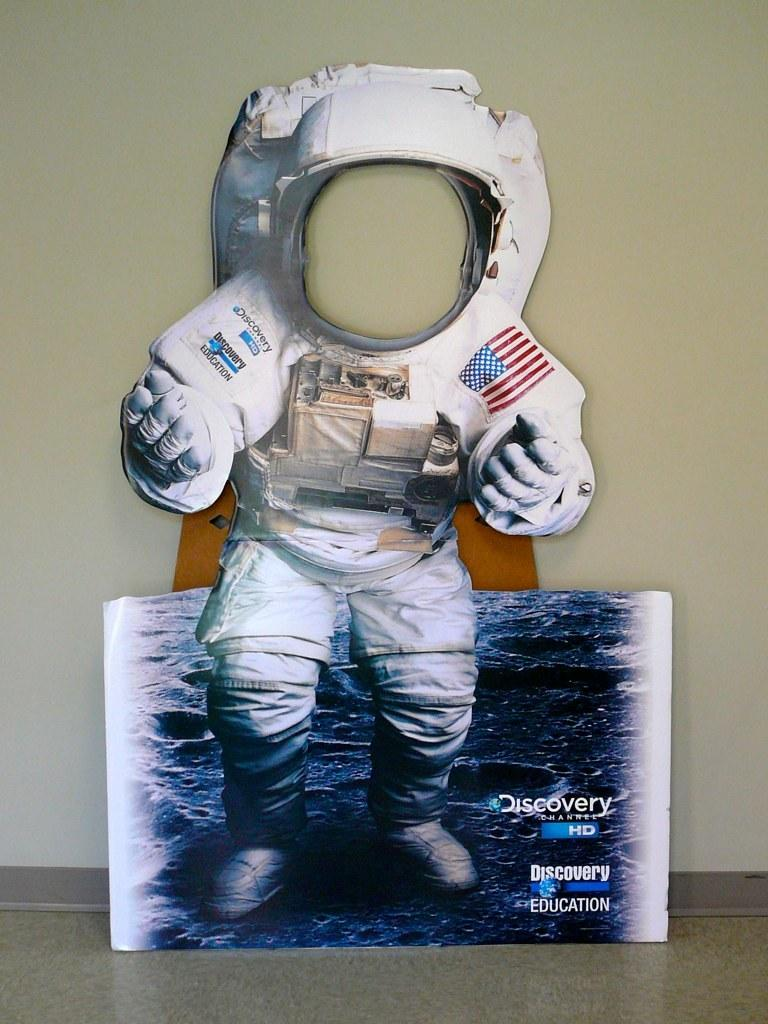Where might the image have been taken? The image might be taken inside a room. What is the main subject in the middle of the image? There is an image of an astronaut in the middle of the image. What is present alongside the astronaut in the image? There is a board in the middle of the image. What can be seen in the background of the image? There is a wall visible in the background of the image. What type of mark can be seen on the astronaut's account in the image? There is no mention of a mark or an account related to the astronaut in the image. Is there a doctor present in the image? There is no doctor visible in the image. 